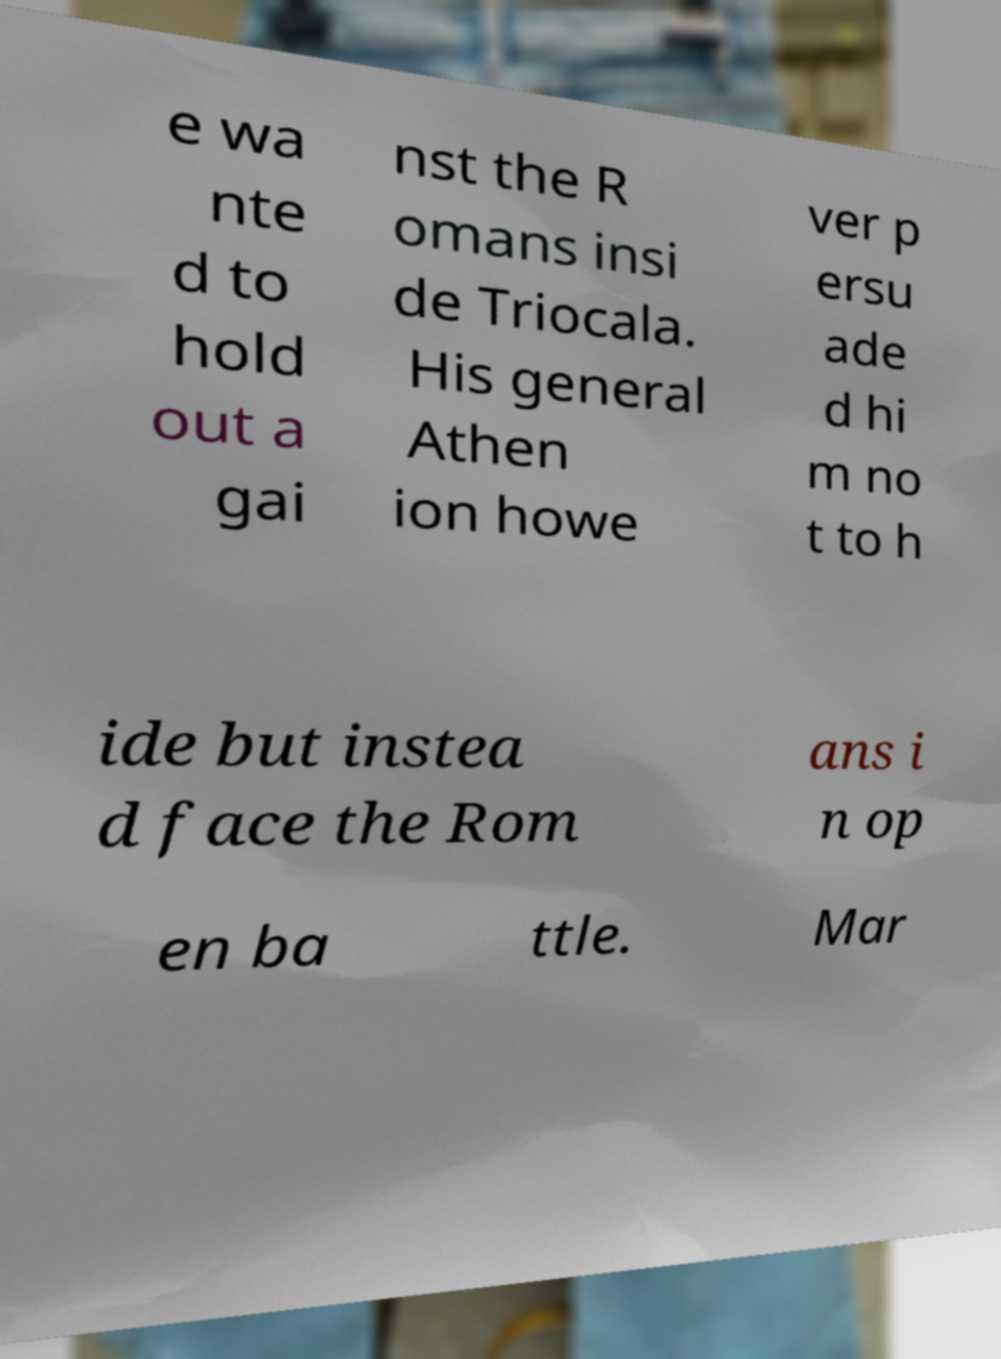Can you accurately transcribe the text from the provided image for me? e wa nte d to hold out a gai nst the R omans insi de Triocala. His general Athen ion howe ver p ersu ade d hi m no t to h ide but instea d face the Rom ans i n op en ba ttle. Mar 